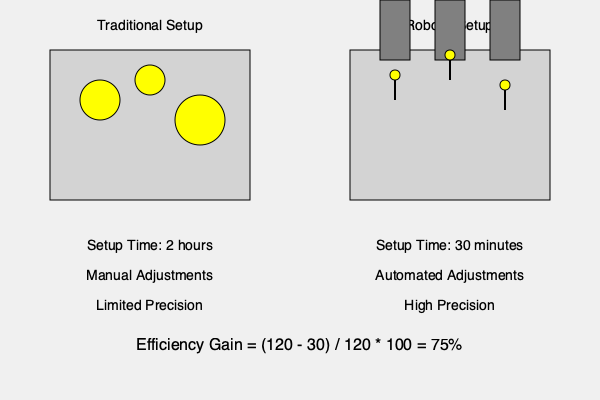Based on the visual comparison of traditional vs. robotic lighting setups for film scenes, what is the percentage increase in efficiency when using robotic lighting in terms of setup time? To calculate the percentage increase in efficiency, we need to follow these steps:

1. Identify the setup times:
   - Traditional setup time: 2 hours = 120 minutes
   - Robotic setup time: 30 minutes

2. Calculate the time saved:
   Time saved = Traditional setup time - Robotic setup time
   Time saved = 120 minutes - 30 minutes = 90 minutes

3. Calculate the efficiency gain:
   Efficiency gain = (Time saved / Traditional setup time) * 100
   Efficiency gain = (90 minutes / 120 minutes) * 100
   Efficiency gain = 0.75 * 100 = 75%

The robotic lighting setup saves 75% of the time compared to the traditional setup, which represents a 75% increase in efficiency.
Answer: 75% 